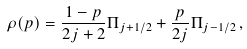Convert formula to latex. <formula><loc_0><loc_0><loc_500><loc_500>\rho ( p ) = \frac { 1 - p } { 2 j + 2 } \Pi _ { j + 1 / 2 } + \frac { p } { 2 j } \Pi _ { j - 1 / 2 } \, ,</formula> 